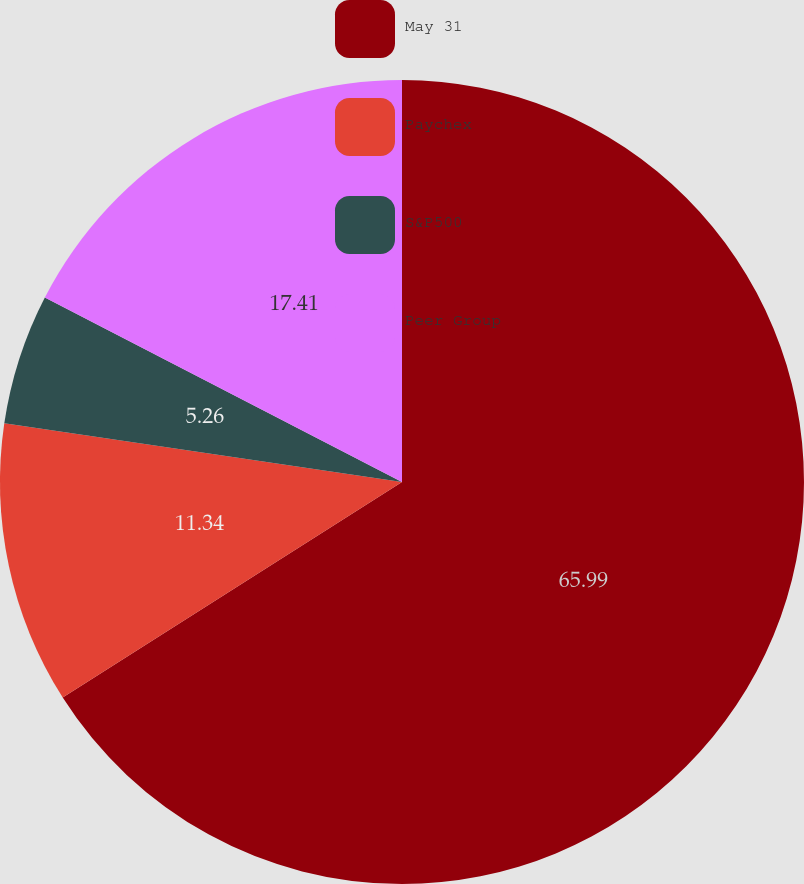Convert chart. <chart><loc_0><loc_0><loc_500><loc_500><pie_chart><fcel>May 31<fcel>Paychex<fcel>S&P500<fcel>Peer Group<nl><fcel>65.99%<fcel>11.34%<fcel>5.26%<fcel>17.41%<nl></chart> 